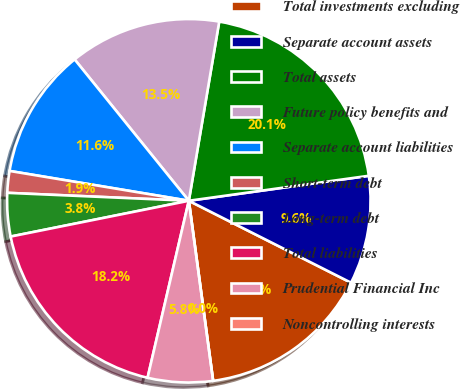Convert chart. <chart><loc_0><loc_0><loc_500><loc_500><pie_chart><fcel>Total investments excluding<fcel>Separate account assets<fcel>Total assets<fcel>Future policy benefits and<fcel>Separate account liabilities<fcel>Short-term debt<fcel>Long-term debt<fcel>Total liabilities<fcel>Prudential Financial Inc<fcel>Noncontrolling interests<nl><fcel>15.42%<fcel>9.64%<fcel>20.13%<fcel>13.49%<fcel>11.56%<fcel>1.93%<fcel>3.85%<fcel>18.2%<fcel>5.78%<fcel>0.0%<nl></chart> 